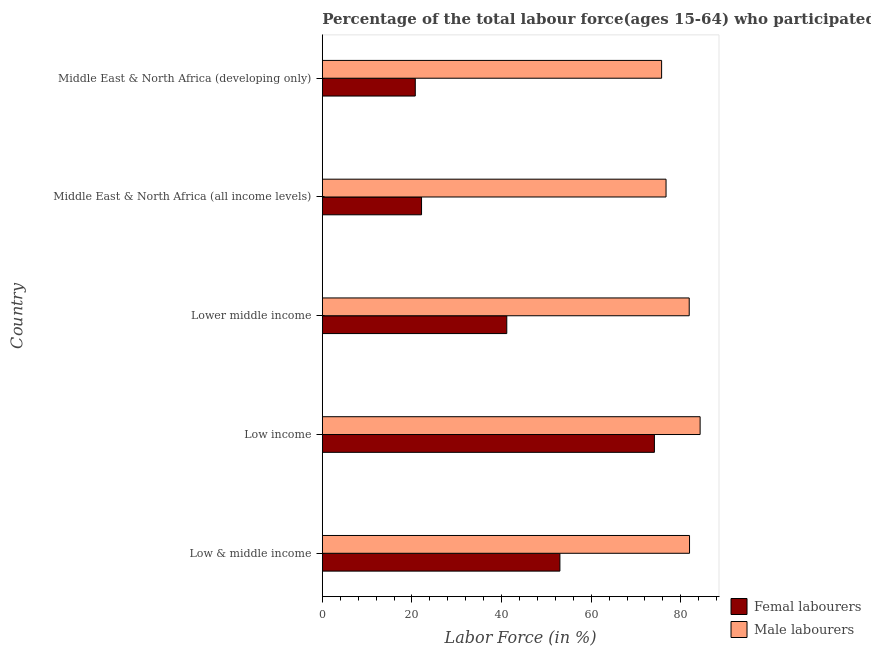How many different coloured bars are there?
Make the answer very short. 2. Are the number of bars per tick equal to the number of legend labels?
Offer a terse response. Yes. Are the number of bars on each tick of the Y-axis equal?
Your response must be concise. Yes. How many bars are there on the 5th tick from the top?
Make the answer very short. 2. What is the percentage of female labor force in Low income?
Provide a succinct answer. 74.11. Across all countries, what is the maximum percentage of male labour force?
Give a very brief answer. 84.31. Across all countries, what is the minimum percentage of male labour force?
Your response must be concise. 75.71. In which country was the percentage of male labour force minimum?
Keep it short and to the point. Middle East & North Africa (developing only). What is the total percentage of male labour force in the graph?
Your answer should be compact. 400.54. What is the difference between the percentage of female labor force in Lower middle income and that in Middle East & North Africa (all income levels)?
Provide a short and direct response. 19.02. What is the difference between the percentage of female labor force in Low & middle income and the percentage of male labour force in Lower middle income?
Make the answer very short. -28.86. What is the average percentage of female labor force per country?
Keep it short and to the point. 42.23. What is the difference between the percentage of female labor force and percentage of male labour force in Middle East & North Africa (developing only)?
Offer a very short reply. -54.97. What is the ratio of the percentage of female labor force in Low & middle income to that in Low income?
Give a very brief answer. 0.71. Is the difference between the percentage of male labour force in Low & middle income and Lower middle income greater than the difference between the percentage of female labor force in Low & middle income and Lower middle income?
Offer a very short reply. No. What is the difference between the highest and the second highest percentage of male labour force?
Your response must be concise. 2.36. What is the difference between the highest and the lowest percentage of female labor force?
Offer a terse response. 53.36. Is the sum of the percentage of female labor force in Low & middle income and Middle East & North Africa (developing only) greater than the maximum percentage of male labour force across all countries?
Your answer should be compact. No. What does the 2nd bar from the top in Low & middle income represents?
Offer a very short reply. Femal labourers. What does the 1st bar from the bottom in Lower middle income represents?
Give a very brief answer. Femal labourers. Does the graph contain any zero values?
Provide a short and direct response. No. Does the graph contain grids?
Offer a terse response. No. How are the legend labels stacked?
Give a very brief answer. Vertical. What is the title of the graph?
Offer a terse response. Percentage of the total labour force(ages 15-64) who participated in production in 2010. What is the label or title of the X-axis?
Provide a succinct answer. Labor Force (in %). What is the label or title of the Y-axis?
Keep it short and to the point. Country. What is the Labor Force (in %) of Femal labourers in Low & middle income?
Make the answer very short. 53.02. What is the Labor Force (in %) of Male labourers in Low & middle income?
Your answer should be compact. 81.94. What is the Labor Force (in %) of Femal labourers in Low income?
Keep it short and to the point. 74.11. What is the Labor Force (in %) of Male labourers in Low income?
Your answer should be very brief. 84.31. What is the Labor Force (in %) in Femal labourers in Lower middle income?
Offer a terse response. 41.16. What is the Labor Force (in %) in Male labourers in Lower middle income?
Offer a terse response. 81.87. What is the Labor Force (in %) of Femal labourers in Middle East & North Africa (all income levels)?
Provide a short and direct response. 22.14. What is the Labor Force (in %) of Male labourers in Middle East & North Africa (all income levels)?
Offer a terse response. 76.7. What is the Labor Force (in %) of Femal labourers in Middle East & North Africa (developing only)?
Your response must be concise. 20.74. What is the Labor Force (in %) in Male labourers in Middle East & North Africa (developing only)?
Ensure brevity in your answer.  75.71. Across all countries, what is the maximum Labor Force (in %) of Femal labourers?
Provide a short and direct response. 74.11. Across all countries, what is the maximum Labor Force (in %) in Male labourers?
Make the answer very short. 84.31. Across all countries, what is the minimum Labor Force (in %) of Femal labourers?
Offer a very short reply. 20.74. Across all countries, what is the minimum Labor Force (in %) of Male labourers?
Your answer should be compact. 75.71. What is the total Labor Force (in %) in Femal labourers in the graph?
Make the answer very short. 211.17. What is the total Labor Force (in %) in Male labourers in the graph?
Your response must be concise. 400.54. What is the difference between the Labor Force (in %) of Femal labourers in Low & middle income and that in Low income?
Provide a short and direct response. -21.09. What is the difference between the Labor Force (in %) of Male labourers in Low & middle income and that in Low income?
Provide a succinct answer. -2.36. What is the difference between the Labor Force (in %) in Femal labourers in Low & middle income and that in Lower middle income?
Offer a very short reply. 11.86. What is the difference between the Labor Force (in %) of Male labourers in Low & middle income and that in Lower middle income?
Offer a very short reply. 0.07. What is the difference between the Labor Force (in %) in Femal labourers in Low & middle income and that in Middle East & North Africa (all income levels)?
Offer a very short reply. 30.88. What is the difference between the Labor Force (in %) of Male labourers in Low & middle income and that in Middle East & North Africa (all income levels)?
Your answer should be very brief. 5.24. What is the difference between the Labor Force (in %) of Femal labourers in Low & middle income and that in Middle East & North Africa (developing only)?
Provide a succinct answer. 32.28. What is the difference between the Labor Force (in %) of Male labourers in Low & middle income and that in Middle East & North Africa (developing only)?
Give a very brief answer. 6.23. What is the difference between the Labor Force (in %) of Femal labourers in Low income and that in Lower middle income?
Provide a short and direct response. 32.95. What is the difference between the Labor Force (in %) in Male labourers in Low income and that in Lower middle income?
Your response must be concise. 2.43. What is the difference between the Labor Force (in %) in Femal labourers in Low income and that in Middle East & North Africa (all income levels)?
Your response must be concise. 51.97. What is the difference between the Labor Force (in %) of Male labourers in Low income and that in Middle East & North Africa (all income levels)?
Provide a short and direct response. 7.6. What is the difference between the Labor Force (in %) in Femal labourers in Low income and that in Middle East & North Africa (developing only)?
Make the answer very short. 53.36. What is the difference between the Labor Force (in %) in Male labourers in Low income and that in Middle East & North Africa (developing only)?
Give a very brief answer. 8.59. What is the difference between the Labor Force (in %) in Femal labourers in Lower middle income and that in Middle East & North Africa (all income levels)?
Make the answer very short. 19.02. What is the difference between the Labor Force (in %) of Male labourers in Lower middle income and that in Middle East & North Africa (all income levels)?
Your answer should be compact. 5.17. What is the difference between the Labor Force (in %) of Femal labourers in Lower middle income and that in Middle East & North Africa (developing only)?
Provide a succinct answer. 20.42. What is the difference between the Labor Force (in %) in Male labourers in Lower middle income and that in Middle East & North Africa (developing only)?
Provide a succinct answer. 6.16. What is the difference between the Labor Force (in %) of Femal labourers in Middle East & North Africa (all income levels) and that in Middle East & North Africa (developing only)?
Your answer should be compact. 1.4. What is the difference between the Labor Force (in %) in Male labourers in Middle East & North Africa (all income levels) and that in Middle East & North Africa (developing only)?
Ensure brevity in your answer.  0.99. What is the difference between the Labor Force (in %) of Femal labourers in Low & middle income and the Labor Force (in %) of Male labourers in Low income?
Provide a short and direct response. -31.29. What is the difference between the Labor Force (in %) in Femal labourers in Low & middle income and the Labor Force (in %) in Male labourers in Lower middle income?
Offer a terse response. -28.86. What is the difference between the Labor Force (in %) of Femal labourers in Low & middle income and the Labor Force (in %) of Male labourers in Middle East & North Africa (all income levels)?
Offer a terse response. -23.68. What is the difference between the Labor Force (in %) in Femal labourers in Low & middle income and the Labor Force (in %) in Male labourers in Middle East & North Africa (developing only)?
Give a very brief answer. -22.7. What is the difference between the Labor Force (in %) of Femal labourers in Low income and the Labor Force (in %) of Male labourers in Lower middle income?
Ensure brevity in your answer.  -7.77. What is the difference between the Labor Force (in %) of Femal labourers in Low income and the Labor Force (in %) of Male labourers in Middle East & North Africa (all income levels)?
Your response must be concise. -2.6. What is the difference between the Labor Force (in %) of Femal labourers in Low income and the Labor Force (in %) of Male labourers in Middle East & North Africa (developing only)?
Your answer should be very brief. -1.61. What is the difference between the Labor Force (in %) in Femal labourers in Lower middle income and the Labor Force (in %) in Male labourers in Middle East & North Africa (all income levels)?
Make the answer very short. -35.54. What is the difference between the Labor Force (in %) in Femal labourers in Lower middle income and the Labor Force (in %) in Male labourers in Middle East & North Africa (developing only)?
Give a very brief answer. -34.55. What is the difference between the Labor Force (in %) in Femal labourers in Middle East & North Africa (all income levels) and the Labor Force (in %) in Male labourers in Middle East & North Africa (developing only)?
Offer a very short reply. -53.57. What is the average Labor Force (in %) in Femal labourers per country?
Offer a terse response. 42.23. What is the average Labor Force (in %) in Male labourers per country?
Your answer should be compact. 80.11. What is the difference between the Labor Force (in %) in Femal labourers and Labor Force (in %) in Male labourers in Low & middle income?
Ensure brevity in your answer.  -28.93. What is the difference between the Labor Force (in %) in Femal labourers and Labor Force (in %) in Male labourers in Low income?
Your answer should be compact. -10.2. What is the difference between the Labor Force (in %) in Femal labourers and Labor Force (in %) in Male labourers in Lower middle income?
Offer a very short reply. -40.71. What is the difference between the Labor Force (in %) of Femal labourers and Labor Force (in %) of Male labourers in Middle East & North Africa (all income levels)?
Provide a short and direct response. -54.56. What is the difference between the Labor Force (in %) in Femal labourers and Labor Force (in %) in Male labourers in Middle East & North Africa (developing only)?
Your response must be concise. -54.97. What is the ratio of the Labor Force (in %) of Femal labourers in Low & middle income to that in Low income?
Your response must be concise. 0.72. What is the ratio of the Labor Force (in %) in Femal labourers in Low & middle income to that in Lower middle income?
Give a very brief answer. 1.29. What is the ratio of the Labor Force (in %) in Femal labourers in Low & middle income to that in Middle East & North Africa (all income levels)?
Ensure brevity in your answer.  2.39. What is the ratio of the Labor Force (in %) of Male labourers in Low & middle income to that in Middle East & North Africa (all income levels)?
Offer a very short reply. 1.07. What is the ratio of the Labor Force (in %) of Femal labourers in Low & middle income to that in Middle East & North Africa (developing only)?
Make the answer very short. 2.56. What is the ratio of the Labor Force (in %) of Male labourers in Low & middle income to that in Middle East & North Africa (developing only)?
Your answer should be very brief. 1.08. What is the ratio of the Labor Force (in %) of Femal labourers in Low income to that in Lower middle income?
Ensure brevity in your answer.  1.8. What is the ratio of the Labor Force (in %) of Male labourers in Low income to that in Lower middle income?
Offer a terse response. 1.03. What is the ratio of the Labor Force (in %) of Femal labourers in Low income to that in Middle East & North Africa (all income levels)?
Provide a short and direct response. 3.35. What is the ratio of the Labor Force (in %) in Male labourers in Low income to that in Middle East & North Africa (all income levels)?
Your answer should be compact. 1.1. What is the ratio of the Labor Force (in %) of Femal labourers in Low income to that in Middle East & North Africa (developing only)?
Provide a short and direct response. 3.57. What is the ratio of the Labor Force (in %) in Male labourers in Low income to that in Middle East & North Africa (developing only)?
Provide a succinct answer. 1.11. What is the ratio of the Labor Force (in %) of Femal labourers in Lower middle income to that in Middle East & North Africa (all income levels)?
Offer a terse response. 1.86. What is the ratio of the Labor Force (in %) in Male labourers in Lower middle income to that in Middle East & North Africa (all income levels)?
Give a very brief answer. 1.07. What is the ratio of the Labor Force (in %) in Femal labourers in Lower middle income to that in Middle East & North Africa (developing only)?
Your answer should be compact. 1.98. What is the ratio of the Labor Force (in %) of Male labourers in Lower middle income to that in Middle East & North Africa (developing only)?
Give a very brief answer. 1.08. What is the ratio of the Labor Force (in %) of Femal labourers in Middle East & North Africa (all income levels) to that in Middle East & North Africa (developing only)?
Your response must be concise. 1.07. What is the ratio of the Labor Force (in %) in Male labourers in Middle East & North Africa (all income levels) to that in Middle East & North Africa (developing only)?
Provide a succinct answer. 1.01. What is the difference between the highest and the second highest Labor Force (in %) in Femal labourers?
Provide a succinct answer. 21.09. What is the difference between the highest and the second highest Labor Force (in %) in Male labourers?
Keep it short and to the point. 2.36. What is the difference between the highest and the lowest Labor Force (in %) of Femal labourers?
Ensure brevity in your answer.  53.36. What is the difference between the highest and the lowest Labor Force (in %) of Male labourers?
Make the answer very short. 8.59. 